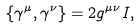Convert formula to latex. <formula><loc_0><loc_0><loc_500><loc_500>\{ \gamma ^ { \mu } , \gamma ^ { \nu } \} = 2 g ^ { \mu \nu } I ,</formula> 